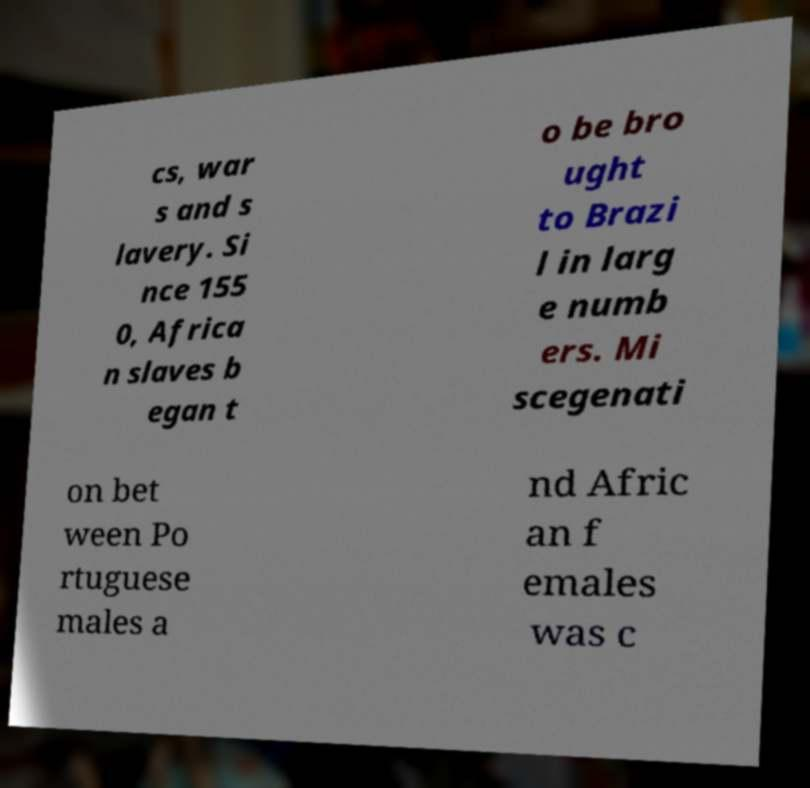Could you assist in decoding the text presented in this image and type it out clearly? cs, war s and s lavery. Si nce 155 0, Africa n slaves b egan t o be bro ught to Brazi l in larg e numb ers. Mi scegenati on bet ween Po rtuguese males a nd Afric an f emales was c 